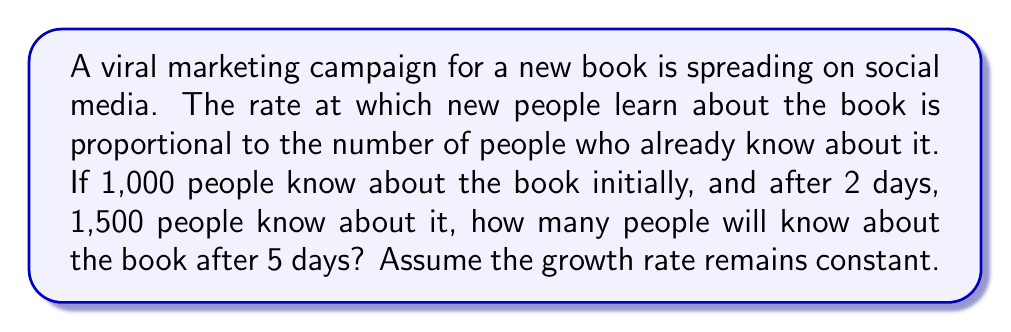Show me your answer to this math problem. Let's approach this step-by-step:

1) Let $P(t)$ be the number of people who know about the book at time $t$ (in days).

2) The rate of change of $P$ with respect to $t$ is proportional to $P$. This can be written as:

   $$\frac{dP}{dt} = kP$$

   where $k$ is the growth rate constant.

3) This is a separable differential equation. The solution is:

   $$P(t) = P_0e^{kt}$$

   where $P_0$ is the initial number of people who know about the book.

4) We're given that $P_0 = 1000$ and $P(2) = 1500$. Let's use these to find $k$:

   $$1500 = 1000e^{2k}$$

5) Solving for $k$:

   $$e^{2k} = 1.5$$
   $$2k = \ln(1.5)$$
   $$k = \frac{\ln(1.5)}{2} \approx 0.2027$$

6) Now that we have $k$, we can use the equation to find $P(5)$:

   $$P(5) = 1000e^{0.2027 * 5}$$

7) Using a calculator (or computer):

   $$P(5) \approx 2746.07$$

Therefore, after 5 days, approximately 2,746 people will know about the book.
Answer: Approximately 2,746 people will know about the book after 5 days. 